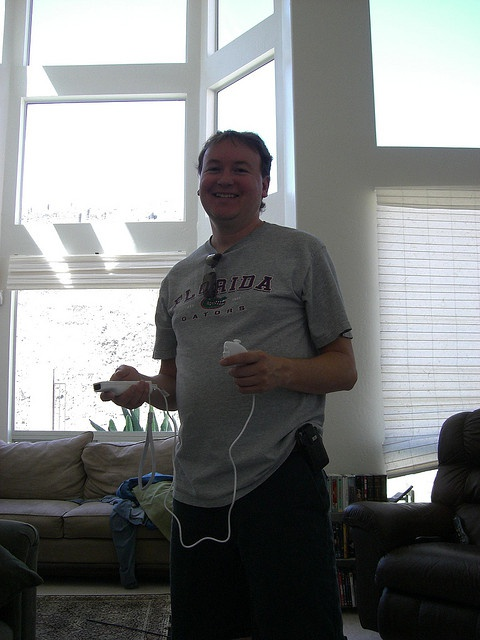Describe the objects in this image and their specific colors. I can see people in white, black, and gray tones, couch in white, black, and gray tones, chair in white, black, and gray tones, couch in white, black, gray, and lightgray tones, and cell phone in white, black, and gray tones in this image. 